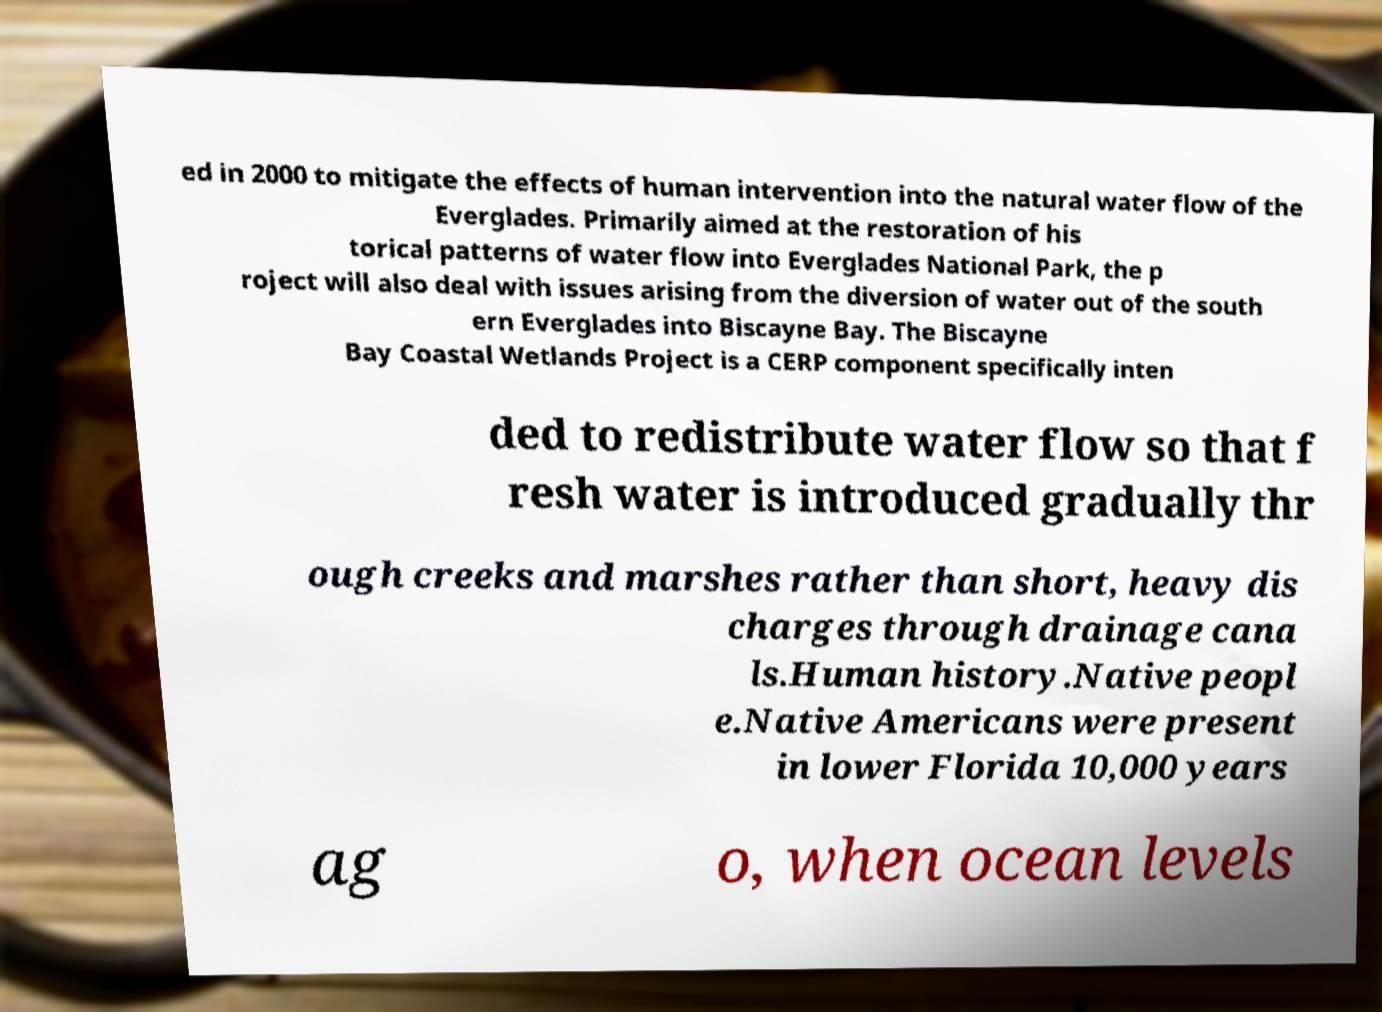Please identify and transcribe the text found in this image. ed in 2000 to mitigate the effects of human intervention into the natural water flow of the Everglades. Primarily aimed at the restoration of his torical patterns of water flow into Everglades National Park, the p roject will also deal with issues arising from the diversion of water out of the south ern Everglades into Biscayne Bay. The Biscayne Bay Coastal Wetlands Project is a CERP component specifically inten ded to redistribute water flow so that f resh water is introduced gradually thr ough creeks and marshes rather than short, heavy dis charges through drainage cana ls.Human history.Native peopl e.Native Americans were present in lower Florida 10,000 years ag o, when ocean levels 